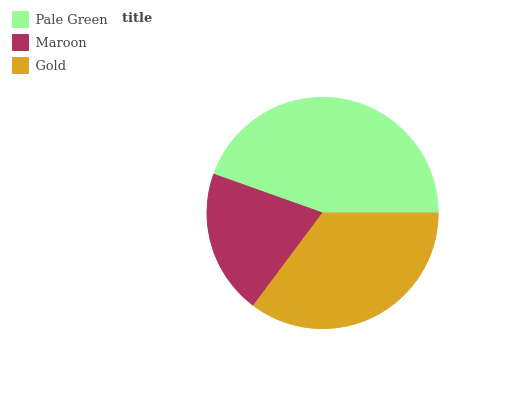Is Maroon the minimum?
Answer yes or no. Yes. Is Pale Green the maximum?
Answer yes or no. Yes. Is Gold the minimum?
Answer yes or no. No. Is Gold the maximum?
Answer yes or no. No. Is Gold greater than Maroon?
Answer yes or no. Yes. Is Maroon less than Gold?
Answer yes or no. Yes. Is Maroon greater than Gold?
Answer yes or no. No. Is Gold less than Maroon?
Answer yes or no. No. Is Gold the high median?
Answer yes or no. Yes. Is Gold the low median?
Answer yes or no. Yes. Is Maroon the high median?
Answer yes or no. No. Is Maroon the low median?
Answer yes or no. No. 